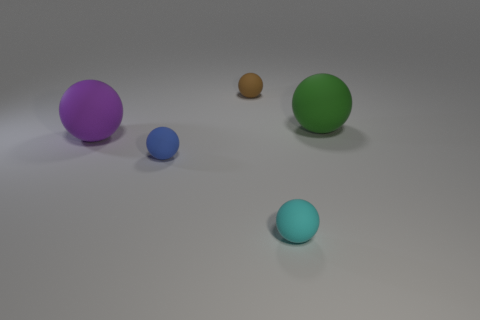Are there fewer purple objects to the left of the green sphere than rubber spheres that are to the right of the purple rubber sphere?
Your answer should be compact. Yes. The matte sphere that is left of the brown sphere and in front of the large purple matte ball is what color?
Your response must be concise. Blue. Does the blue rubber object have the same size as the sphere that is in front of the blue thing?
Give a very brief answer. Yes. What is the shape of the big thing that is right of the brown matte sphere?
Give a very brief answer. Sphere. Are there more large objects to the left of the large green rubber sphere than purple matte cylinders?
Offer a terse response. Yes. What number of things are to the left of the large matte object on the right side of the ball that is left of the small blue matte sphere?
Your answer should be very brief. 4. There is a matte object that is on the right side of the cyan thing; is its size the same as the matte ball that is left of the small blue object?
Your response must be concise. Yes. What is the material of the big sphere that is right of the large ball that is on the left side of the green ball?
Ensure brevity in your answer.  Rubber. What number of things are either balls in front of the large purple matte thing or large green cubes?
Your response must be concise. 2. Are there the same number of small cyan rubber objects behind the cyan matte thing and small brown rubber balls in front of the purple rubber object?
Offer a very short reply. Yes. 